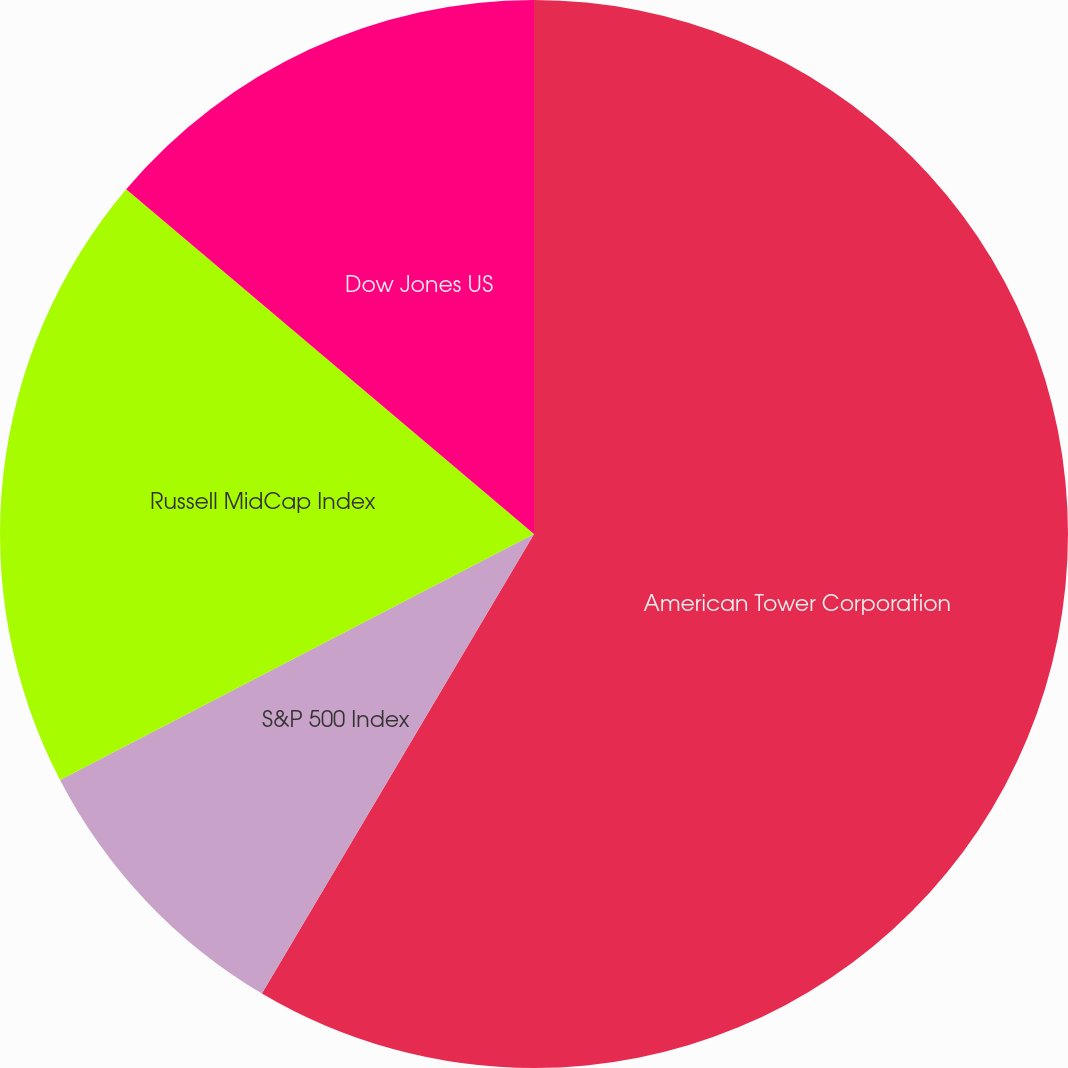Convert chart to OTSL. <chart><loc_0><loc_0><loc_500><loc_500><pie_chart><fcel>American Tower Corporation<fcel>S&P 500 Index<fcel>Russell MidCap Index<fcel>Dow Jones US<nl><fcel>58.51%<fcel>8.87%<fcel>18.79%<fcel>13.83%<nl></chart> 